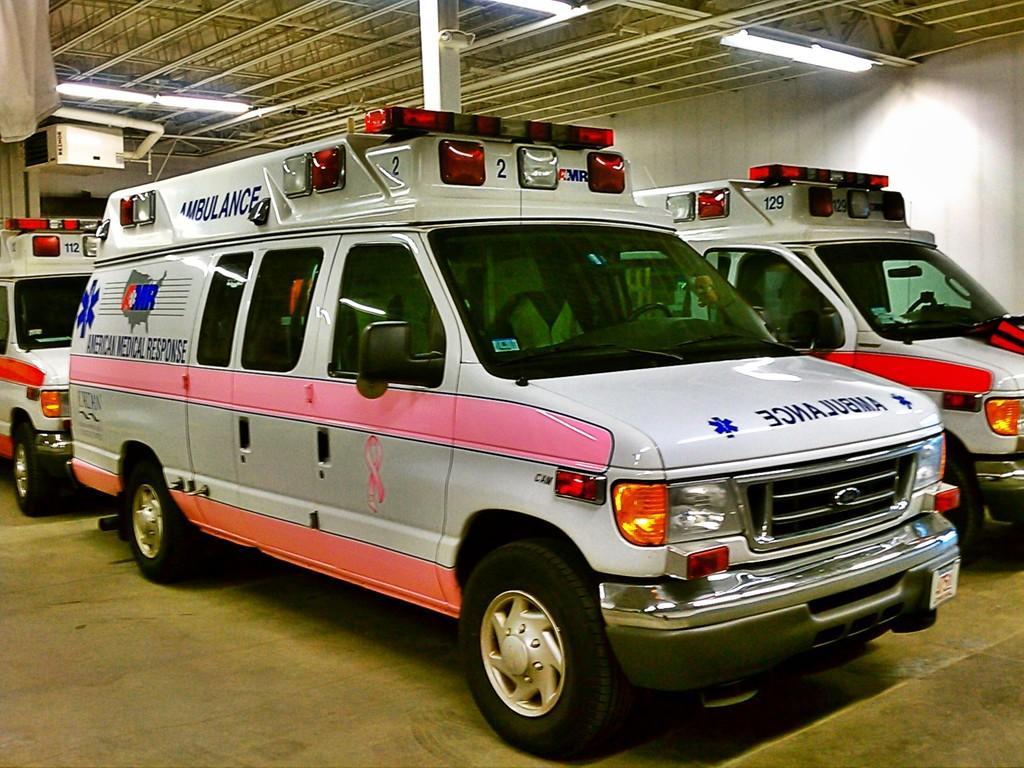In one or two sentences, can you explain what this image depicts? In this picture, we see three ambulances in white, pink and red color. At the bottom, we see the pavement. Behind the vehicles, we see a pole. In the background, we see a white wall. At the top, we see the lights and the roof of the shed. 